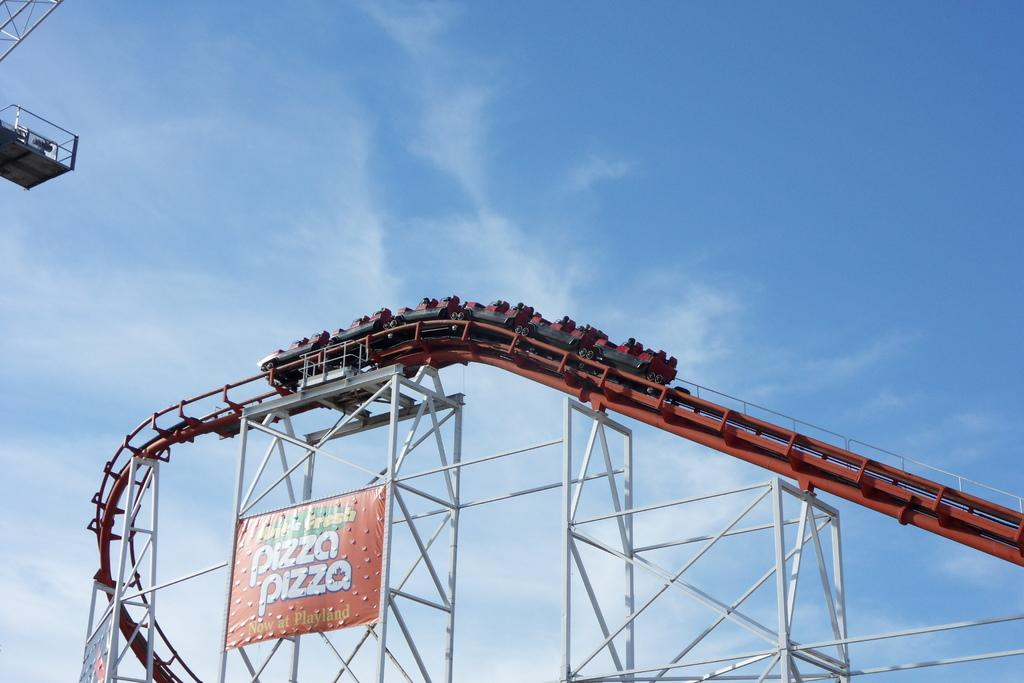<image>
Present a compact description of the photo's key features. A red rollercoaster with a banner attached to it advertising Fresh Pizza available now at Playland. 